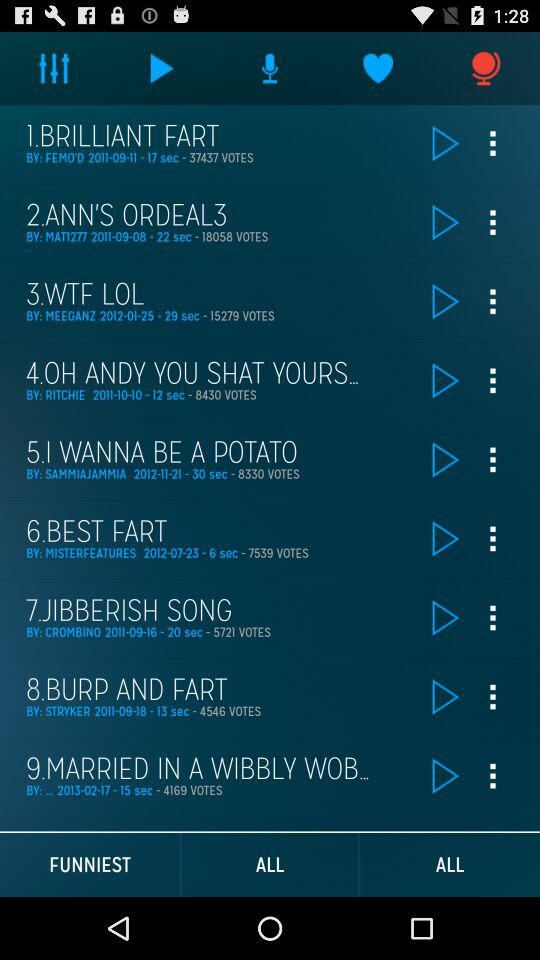What is the time duration of the brilliant fart? The duration of the brilliant fart is 17 seconds. 